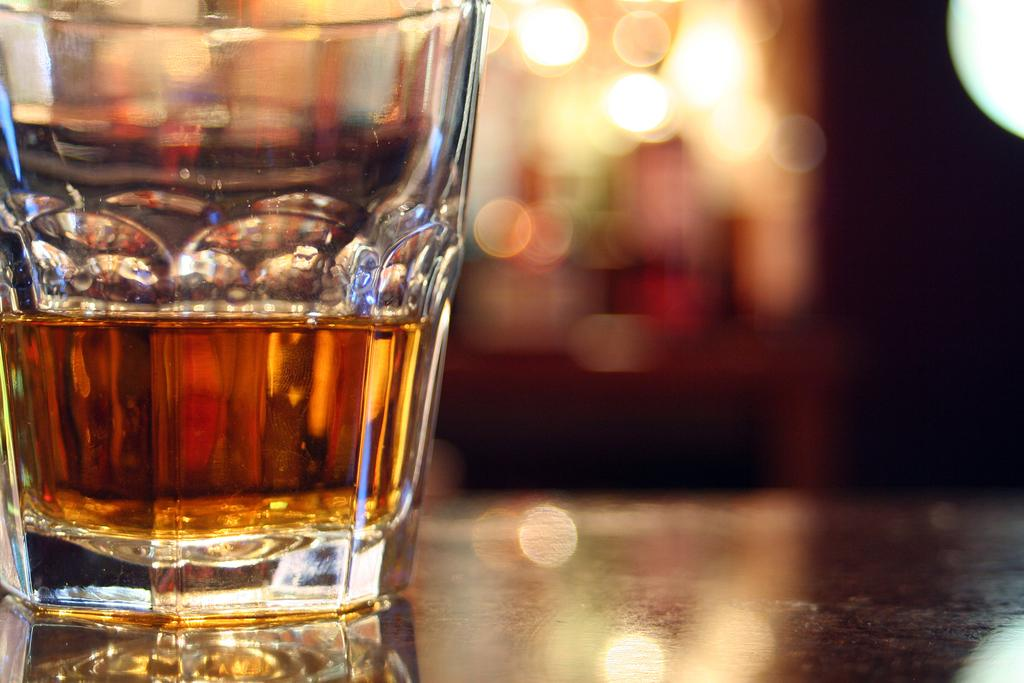What is contained in the glass that is visible in the image? There is a drink in a glass in the image. What type of furniture is present at the bottom of the image? There is a table visible at the bottom of the image. Can you describe the background of the image? The background of the image is blurry. What sense is being stimulated by the cherry in the image? There is no cherry present in the image, so it cannot stimulate any senses. 